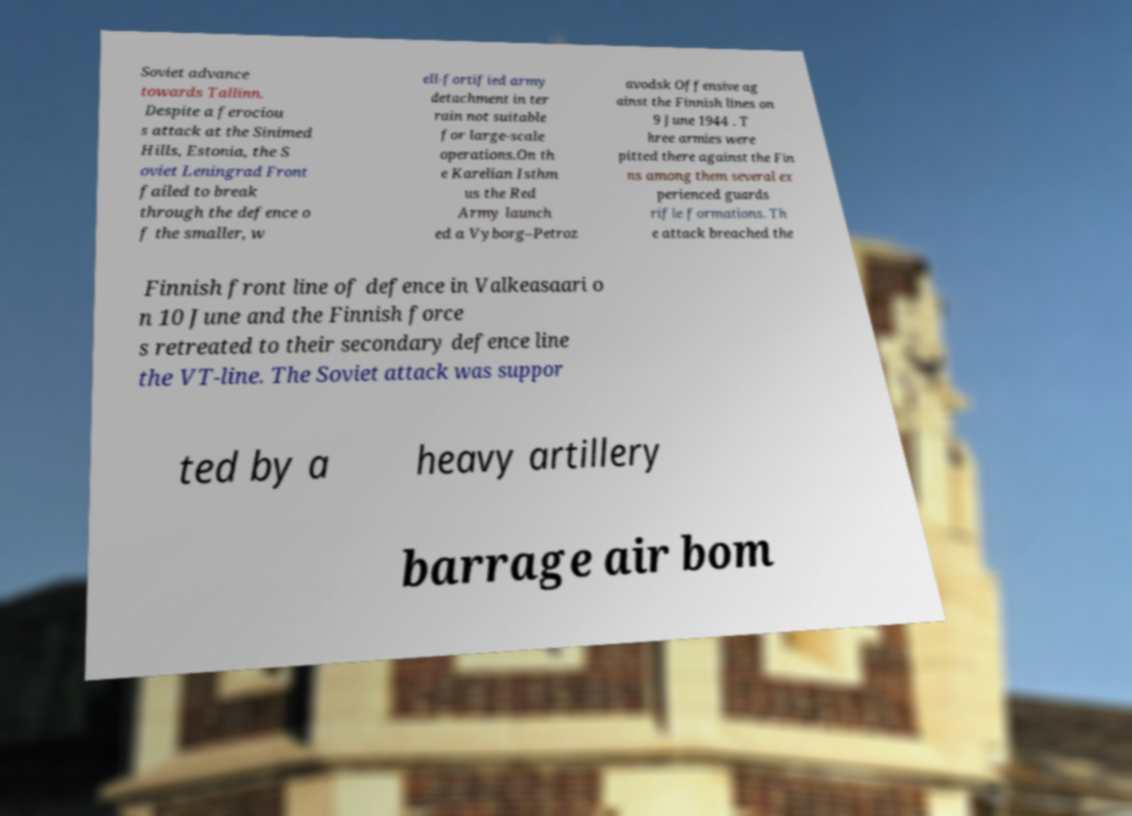What messages or text are displayed in this image? I need them in a readable, typed format. Soviet advance towards Tallinn. Despite a ferociou s attack at the Sinimed Hills, Estonia, the S oviet Leningrad Front failed to break through the defence o f the smaller, w ell-fortified army detachment in ter rain not suitable for large-scale operations.On th e Karelian Isthm us the Red Army launch ed a Vyborg–Petroz avodsk Offensive ag ainst the Finnish lines on 9 June 1944 . T hree armies were pitted there against the Fin ns among them several ex perienced guards rifle formations. Th e attack breached the Finnish front line of defence in Valkeasaari o n 10 June and the Finnish force s retreated to their secondary defence line the VT-line. The Soviet attack was suppor ted by a heavy artillery barrage air bom 